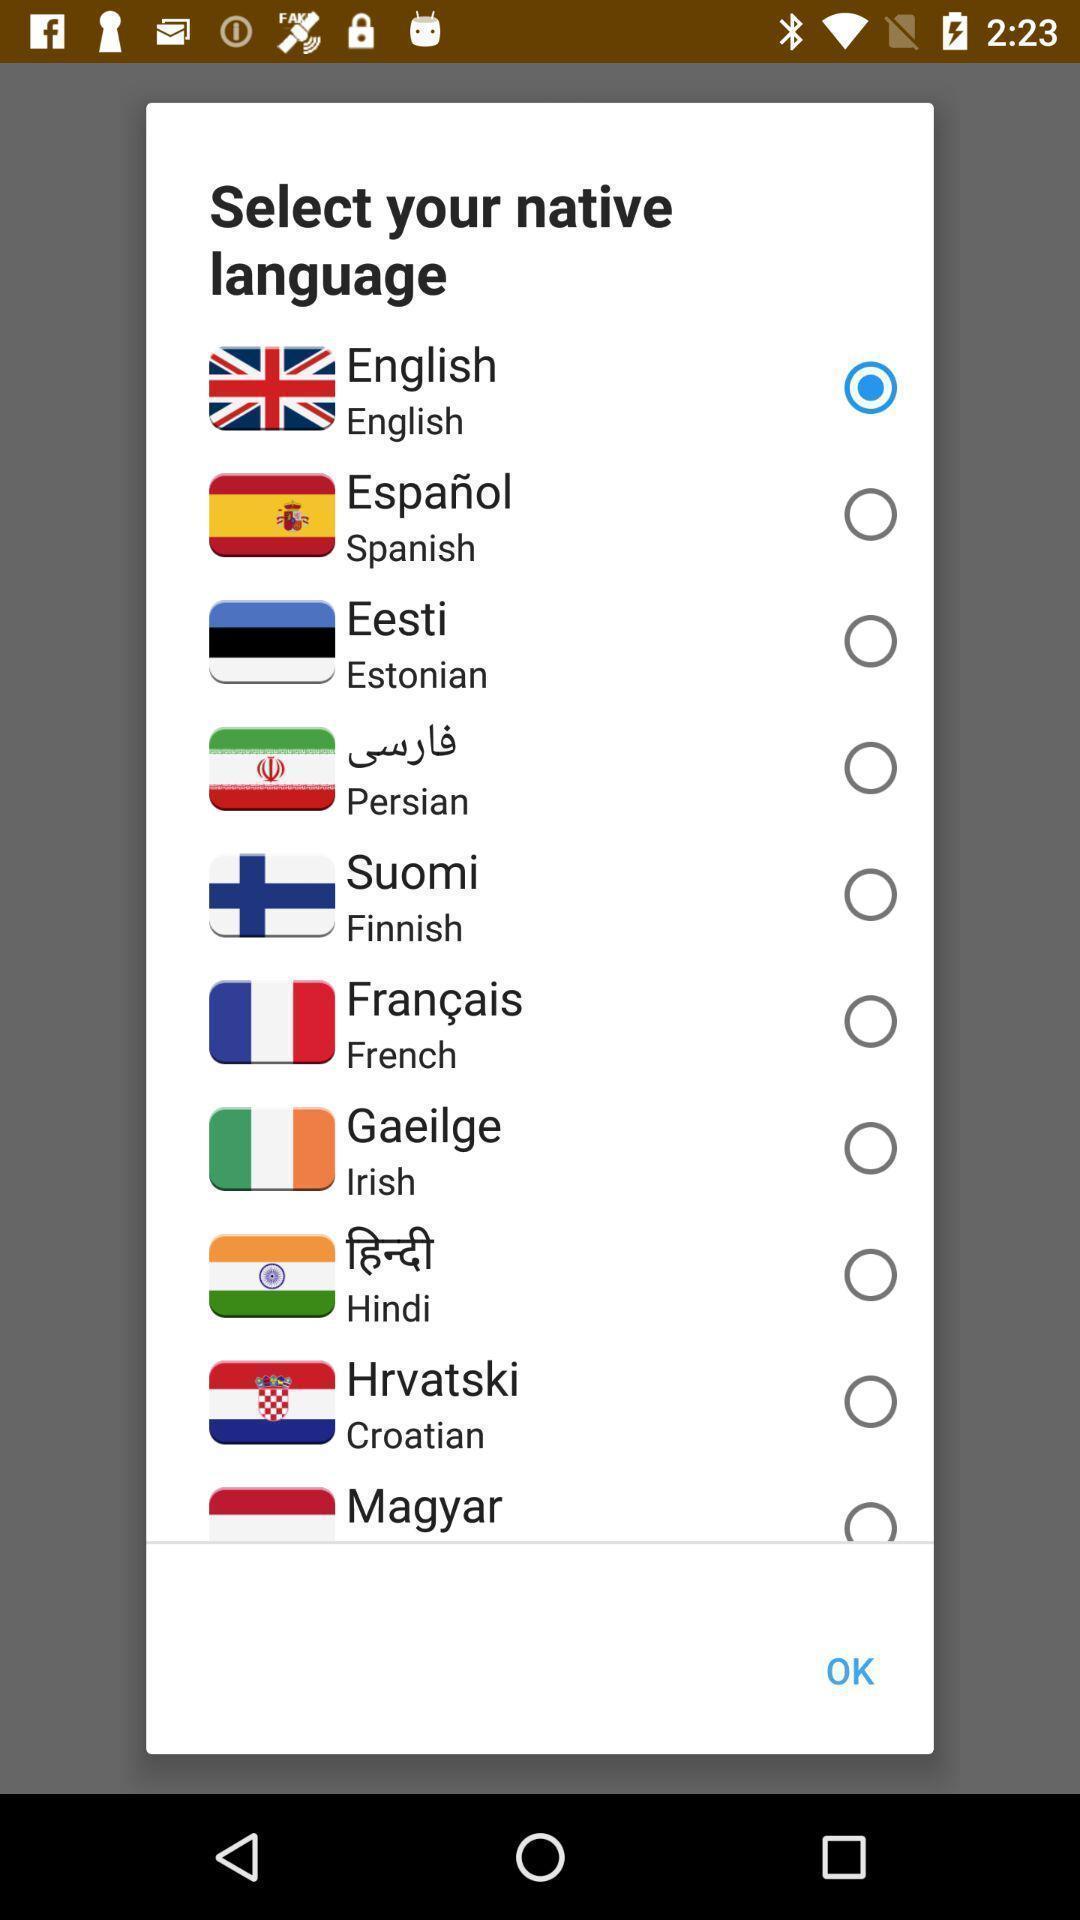Please provide a description for this image. Pop-up showing list of various languages. 